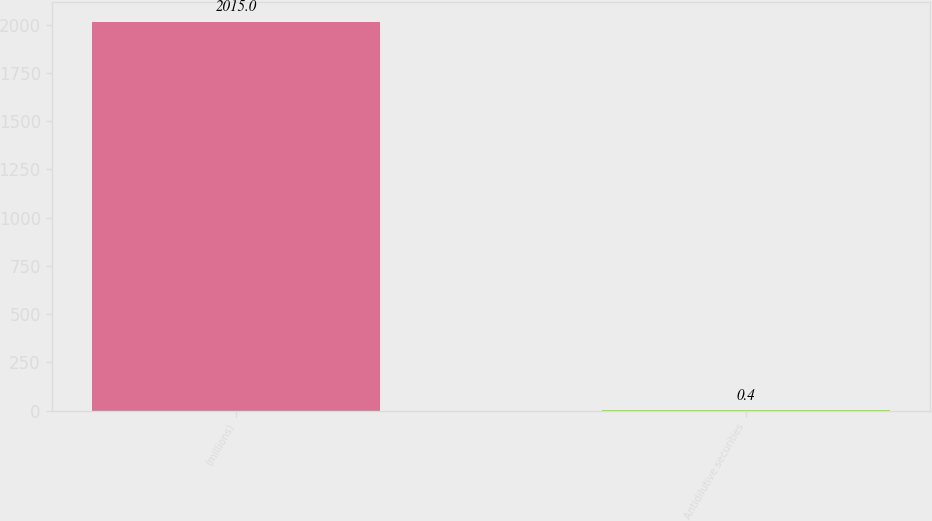<chart> <loc_0><loc_0><loc_500><loc_500><bar_chart><fcel>(millions)<fcel>Antidilutive securities<nl><fcel>2015<fcel>0.4<nl></chart> 